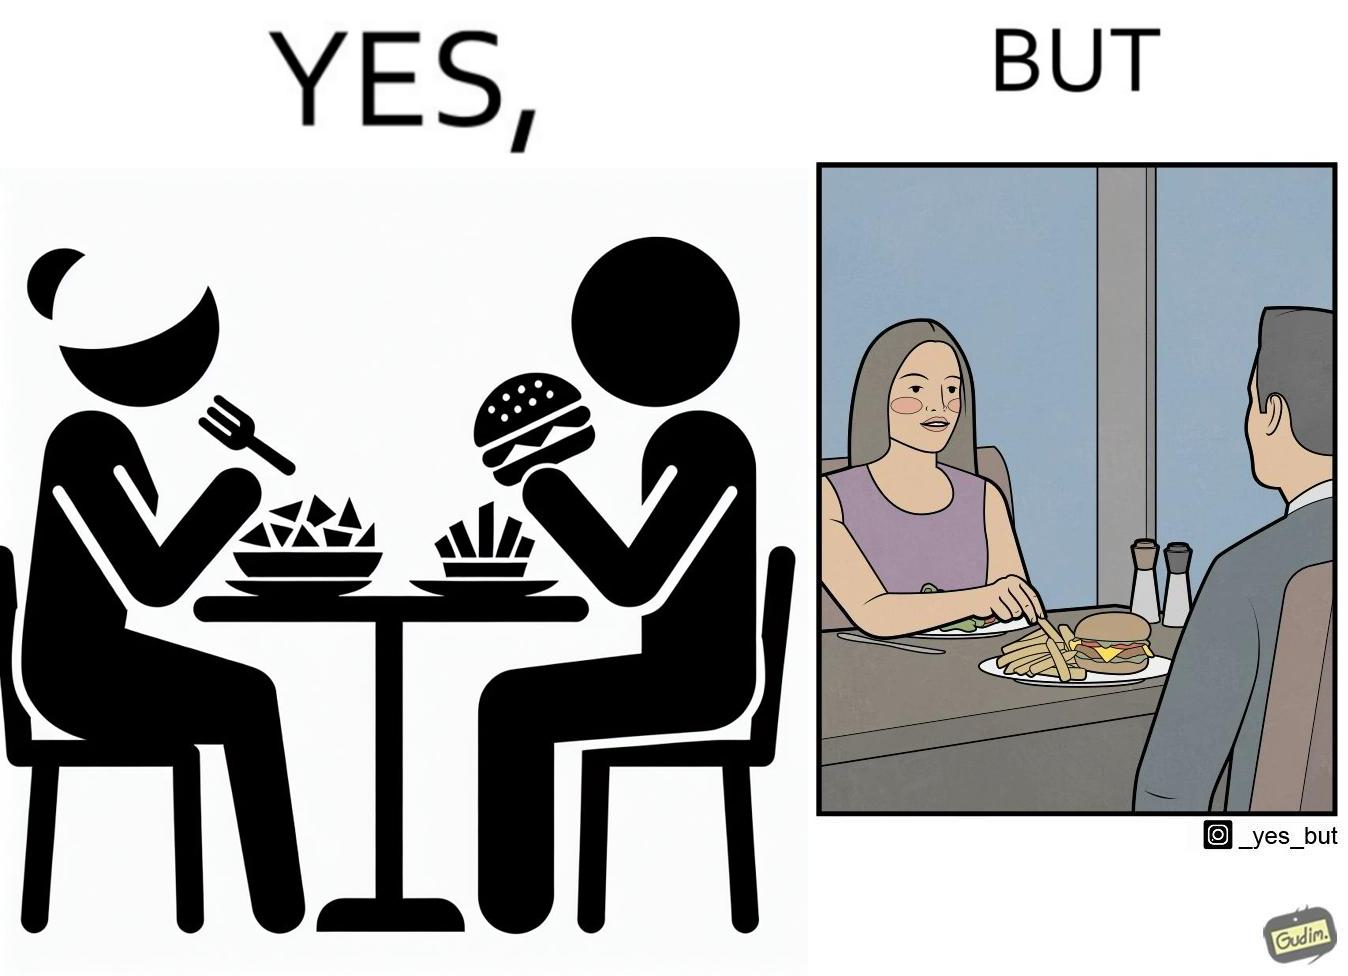Is this image satirical or non-satirical? Yes, this image is satirical. 